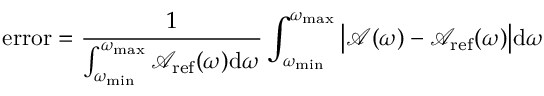Convert formula to latex. <formula><loc_0><loc_0><loc_500><loc_500>e r r o r = \frac { 1 } { \int _ { \omega _ { \min } } ^ { \omega _ { \max } } \mathcal { A } _ { r e f } ( \omega ) d \omega } \int _ { \omega _ { \min } } ^ { \omega _ { \max } } \left | \mathcal { A } ( \omega ) - \mathcal { A } _ { r e f } ( \omega ) \right | d \omega</formula> 